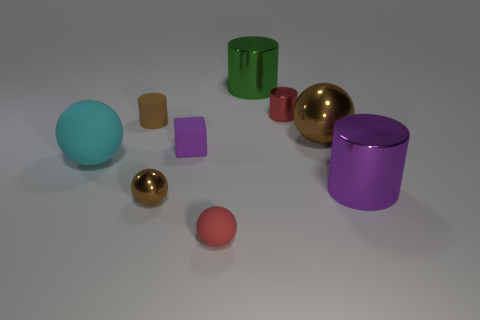Subtract 1 spheres. How many spheres are left? 3 Add 1 small brown metallic things. How many objects exist? 10 Subtract all cubes. How many objects are left? 8 Subtract all tiny spheres. Subtract all tiny gray metallic cylinders. How many objects are left? 7 Add 6 large brown balls. How many large brown balls are left? 7 Add 2 red shiny cylinders. How many red shiny cylinders exist? 3 Subtract 0 cyan cylinders. How many objects are left? 9 